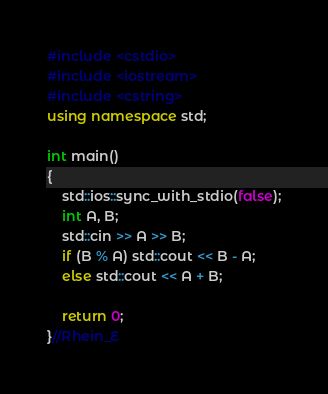Convert code to text. <code><loc_0><loc_0><loc_500><loc_500><_C++_>#include <cstdio>
#include <iostream>
#include <cstring>
using namespace std;

int main()
{
	std::ios::sync_with_stdio(false);
	int A, B;
	std::cin >> A >> B;
	if (B % A) std::cout << B - A;
	else std::cout << A + B;

	return 0;
}//Rhein_E
</code> 